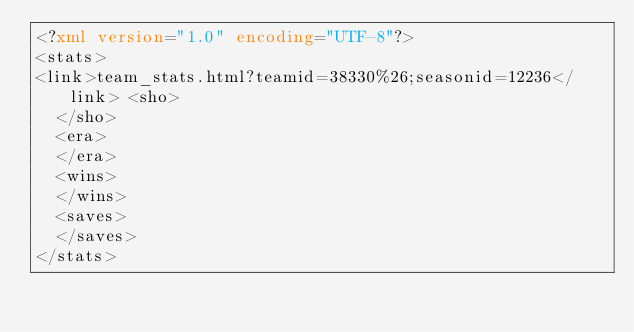<code> <loc_0><loc_0><loc_500><loc_500><_XML_><?xml version="1.0" encoding="UTF-8"?>
<stats>
<link>team_stats.html?teamid=38330%26;seasonid=12236</link>	<sho>
	</sho>
	<era>
	</era>
	<wins>
	</wins>
	<saves>
	</saves>
</stats>
</code> 